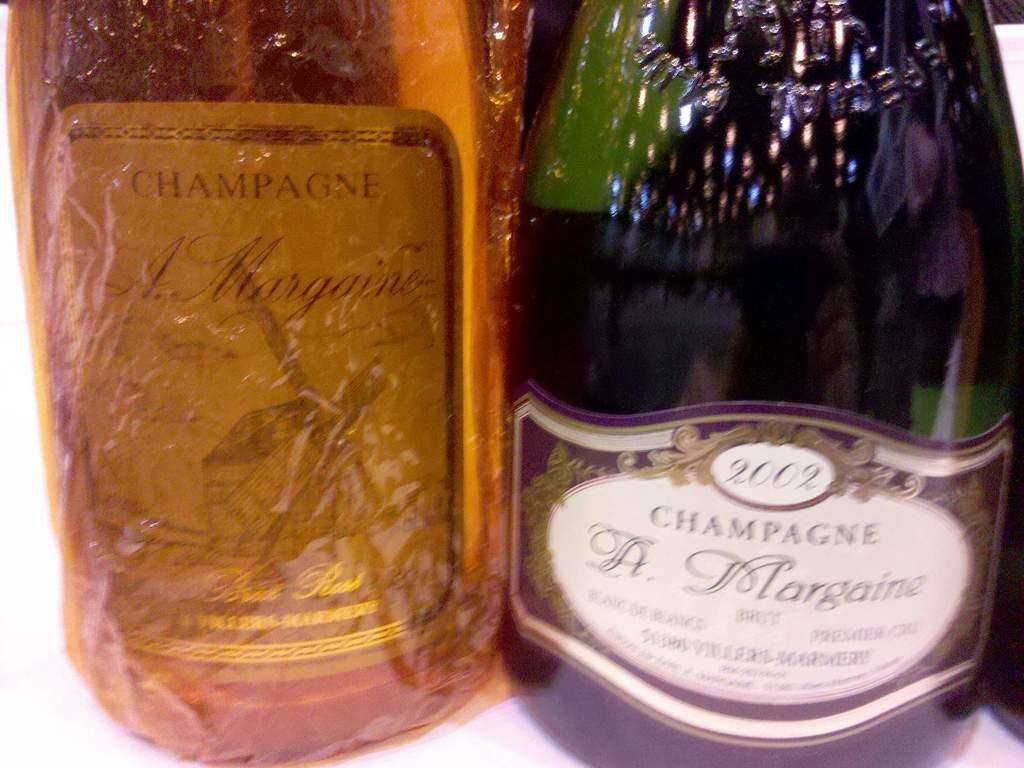How many bottles are visible in the image? There are two bottles in the image. What colors are the bottles? One bottle is yellow, and the other bottle is green. What type of animals can be seen at the zoo in the image? There is no zoo present in the image; it only features two bottles, one yellow and one green. 